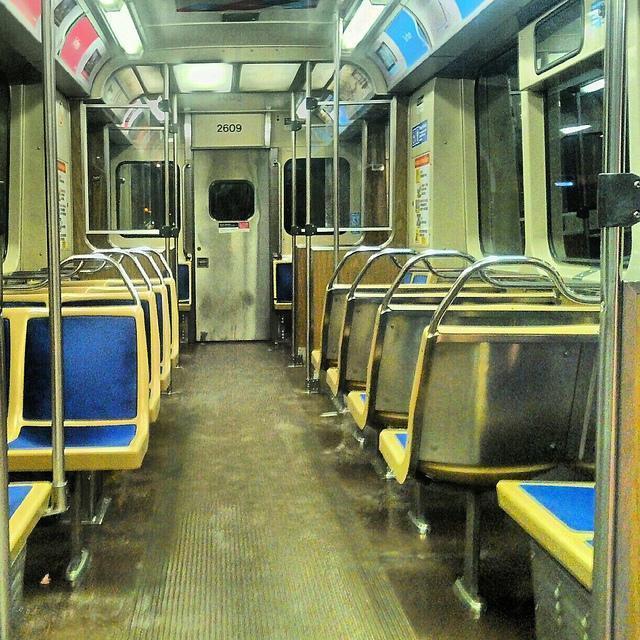How many chairs are there?
Give a very brief answer. 5. How many benches can you see?
Give a very brief answer. 3. How many surfboards are there?
Give a very brief answer. 0. 